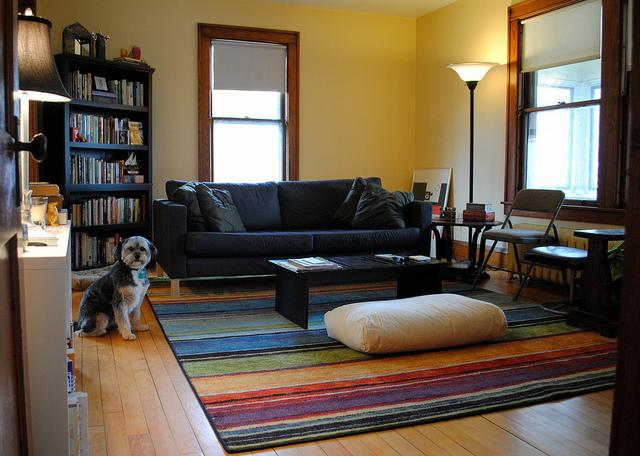What sound does the animal make? Please explain your reasoning. woof. The dog, when it "speaks" will always "woof" or "bark" or "growl", but it never clucks or moos!. 